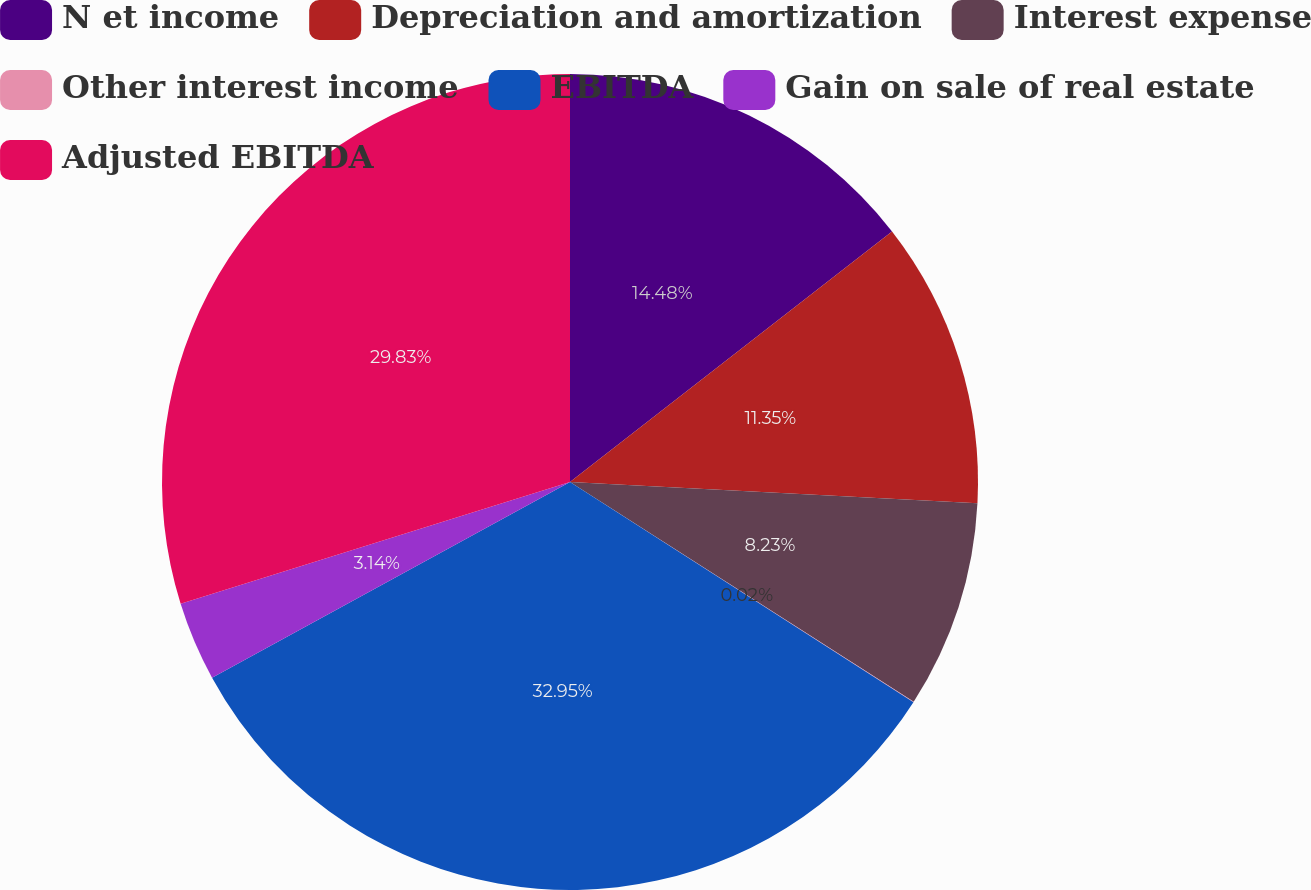<chart> <loc_0><loc_0><loc_500><loc_500><pie_chart><fcel>N et income<fcel>Depreciation and amortization<fcel>Interest expense<fcel>Other interest income<fcel>EBITDA<fcel>Gain on sale of real estate<fcel>Adjusted EBITDA<nl><fcel>14.48%<fcel>11.35%<fcel>8.23%<fcel>0.02%<fcel>32.96%<fcel>3.14%<fcel>29.83%<nl></chart> 